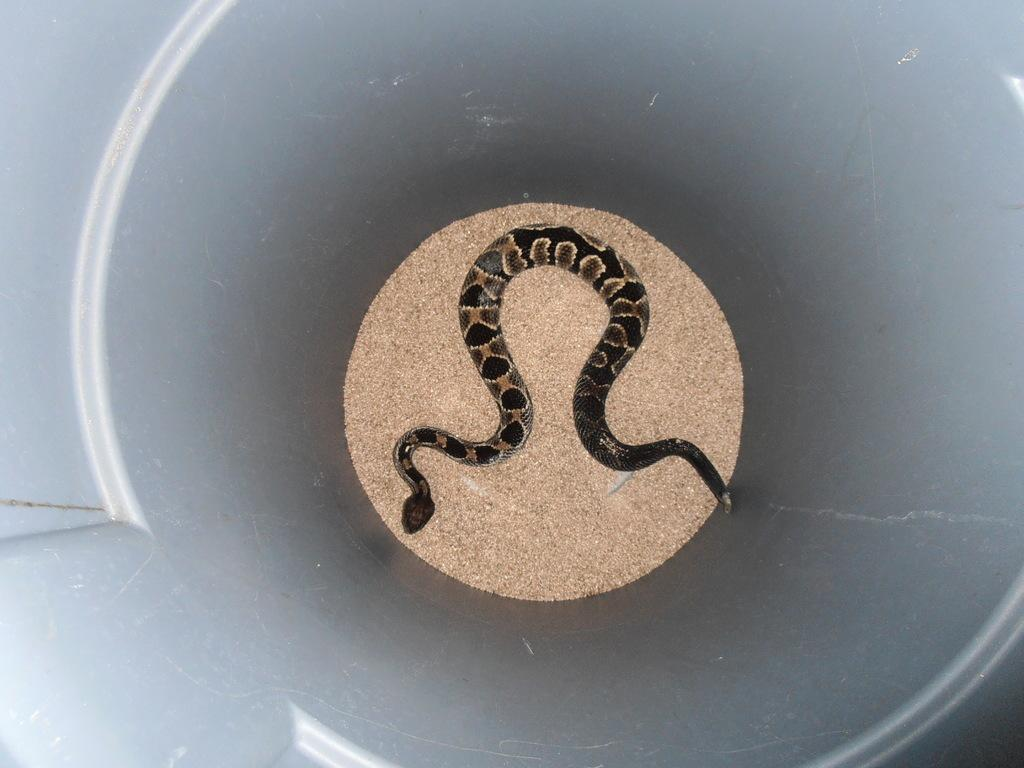What is in the container that is visible in the image? There is a container in the image, and it holds sand. Is there anything else in the container besides sand? Yes, there is a snake in the container. What type of crook can be seen in the image? There is no crook present in the image. How does the snake in the container help improve memory? The image does not show any connection between the snake and memory improvement. 